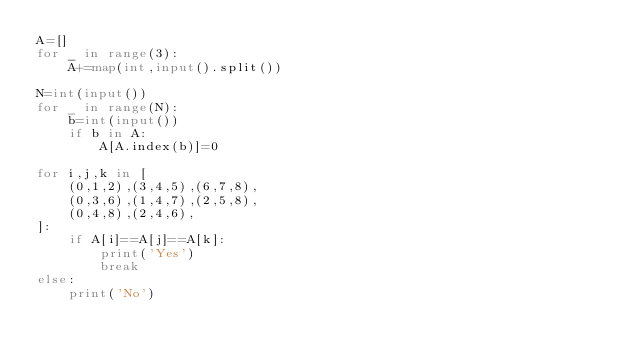Convert code to text. <code><loc_0><loc_0><loc_500><loc_500><_Python_>A=[]
for _ in range(3):
    A+=map(int,input().split())

N=int(input())
for _ in range(N):
    b=int(input())
    if b in A:
        A[A.index(b)]=0

for i,j,k in [
    (0,1,2),(3,4,5),(6,7,8),
    (0,3,6),(1,4,7),(2,5,8),
    (0,4,8),(2,4,6),
]:
    if A[i]==A[j]==A[k]:
        print('Yes')
        break
else:
    print('No')
</code> 